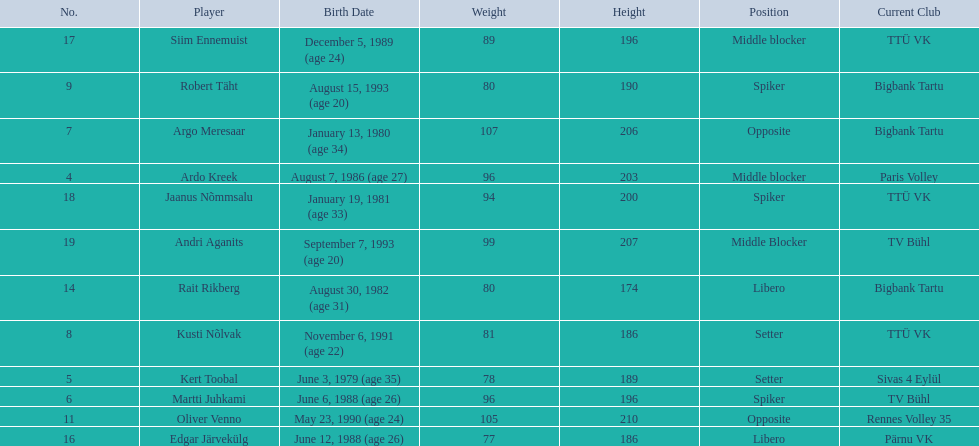Who are the players of the estonian men's national volleyball team? Ardo Kreek, Kert Toobal, Martti Juhkami, Argo Meresaar, Kusti Nõlvak, Robert Täht, Oliver Venno, Rait Rikberg, Edgar Järvekülg, Siim Ennemuist, Jaanus Nõmmsalu, Andri Aganits. Of these, which have a height over 200? Ardo Kreek, Argo Meresaar, Oliver Venno, Andri Aganits. Of the remaining, who is the tallest? Oliver Venno. 